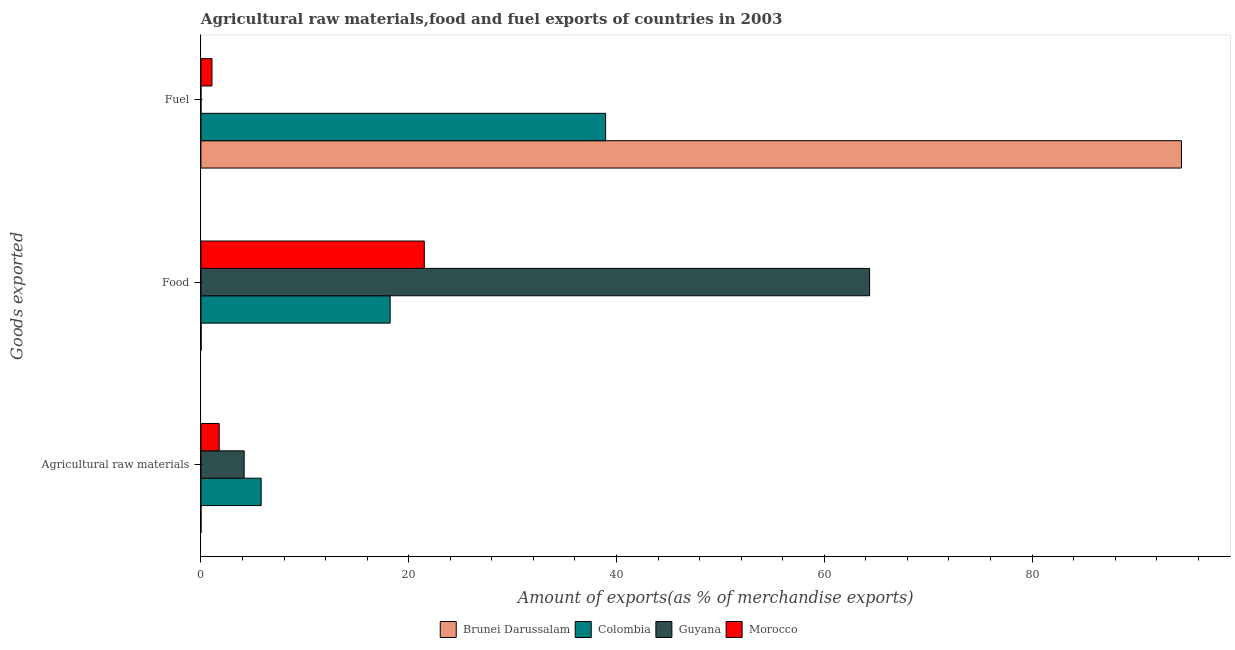How many bars are there on the 1st tick from the top?
Provide a short and direct response. 4. How many bars are there on the 2nd tick from the bottom?
Provide a short and direct response. 4. What is the label of the 1st group of bars from the top?
Keep it short and to the point. Fuel. What is the percentage of raw materials exports in Colombia?
Offer a terse response. 5.8. Across all countries, what is the maximum percentage of raw materials exports?
Give a very brief answer. 5.8. Across all countries, what is the minimum percentage of food exports?
Your response must be concise. 0.02. In which country was the percentage of food exports maximum?
Offer a very short reply. Guyana. In which country was the percentage of fuel exports minimum?
Your answer should be very brief. Guyana. What is the total percentage of food exports in the graph?
Make the answer very short. 104.1. What is the difference between the percentage of food exports in Colombia and that in Morocco?
Offer a terse response. -3.29. What is the difference between the percentage of raw materials exports in Morocco and the percentage of fuel exports in Colombia?
Provide a short and direct response. -37.2. What is the average percentage of fuel exports per country?
Provide a short and direct response. 33.6. What is the difference between the percentage of raw materials exports and percentage of food exports in Colombia?
Offer a terse response. -12.42. In how many countries, is the percentage of fuel exports greater than 60 %?
Offer a terse response. 1. What is the ratio of the percentage of fuel exports in Colombia to that in Brunei Darussalam?
Ensure brevity in your answer.  0.41. Is the percentage of food exports in Brunei Darussalam less than that in Colombia?
Your response must be concise. Yes. What is the difference between the highest and the second highest percentage of food exports?
Offer a very short reply. 42.86. What is the difference between the highest and the lowest percentage of raw materials exports?
Offer a very short reply. 5.8. What does the 1st bar from the bottom in Food represents?
Provide a succinct answer. Brunei Darussalam. Is it the case that in every country, the sum of the percentage of raw materials exports and percentage of food exports is greater than the percentage of fuel exports?
Make the answer very short. No. Are all the bars in the graph horizontal?
Make the answer very short. Yes. How many countries are there in the graph?
Ensure brevity in your answer.  4. Does the graph contain any zero values?
Make the answer very short. No. Does the graph contain grids?
Provide a succinct answer. No. Where does the legend appear in the graph?
Keep it short and to the point. Bottom center. What is the title of the graph?
Offer a terse response. Agricultural raw materials,food and fuel exports of countries in 2003. What is the label or title of the X-axis?
Offer a very short reply. Amount of exports(as % of merchandise exports). What is the label or title of the Y-axis?
Offer a very short reply. Goods exported. What is the Amount of exports(as % of merchandise exports) of Brunei Darussalam in Agricultural raw materials?
Offer a terse response. 0. What is the Amount of exports(as % of merchandise exports) in Colombia in Agricultural raw materials?
Keep it short and to the point. 5.8. What is the Amount of exports(as % of merchandise exports) in Guyana in Agricultural raw materials?
Ensure brevity in your answer.  4.16. What is the Amount of exports(as % of merchandise exports) of Morocco in Agricultural raw materials?
Make the answer very short. 1.76. What is the Amount of exports(as % of merchandise exports) of Brunei Darussalam in Food?
Offer a terse response. 0.02. What is the Amount of exports(as % of merchandise exports) in Colombia in Food?
Make the answer very short. 18.22. What is the Amount of exports(as % of merchandise exports) in Guyana in Food?
Your answer should be very brief. 64.36. What is the Amount of exports(as % of merchandise exports) in Morocco in Food?
Offer a terse response. 21.5. What is the Amount of exports(as % of merchandise exports) in Brunei Darussalam in Fuel?
Your answer should be very brief. 94.38. What is the Amount of exports(as % of merchandise exports) of Colombia in Fuel?
Offer a terse response. 38.95. What is the Amount of exports(as % of merchandise exports) of Guyana in Fuel?
Your response must be concise. 0. What is the Amount of exports(as % of merchandise exports) in Morocco in Fuel?
Your answer should be compact. 1.06. Across all Goods exported, what is the maximum Amount of exports(as % of merchandise exports) in Brunei Darussalam?
Your answer should be compact. 94.38. Across all Goods exported, what is the maximum Amount of exports(as % of merchandise exports) of Colombia?
Make the answer very short. 38.95. Across all Goods exported, what is the maximum Amount of exports(as % of merchandise exports) of Guyana?
Offer a terse response. 64.36. Across all Goods exported, what is the maximum Amount of exports(as % of merchandise exports) of Morocco?
Keep it short and to the point. 21.5. Across all Goods exported, what is the minimum Amount of exports(as % of merchandise exports) in Brunei Darussalam?
Your response must be concise. 0. Across all Goods exported, what is the minimum Amount of exports(as % of merchandise exports) in Colombia?
Your response must be concise. 5.8. Across all Goods exported, what is the minimum Amount of exports(as % of merchandise exports) of Guyana?
Make the answer very short. 0. Across all Goods exported, what is the minimum Amount of exports(as % of merchandise exports) of Morocco?
Provide a short and direct response. 1.06. What is the total Amount of exports(as % of merchandise exports) in Brunei Darussalam in the graph?
Provide a succinct answer. 94.41. What is the total Amount of exports(as % of merchandise exports) in Colombia in the graph?
Ensure brevity in your answer.  62.97. What is the total Amount of exports(as % of merchandise exports) of Guyana in the graph?
Keep it short and to the point. 68.53. What is the total Amount of exports(as % of merchandise exports) of Morocco in the graph?
Your response must be concise. 24.32. What is the difference between the Amount of exports(as % of merchandise exports) in Brunei Darussalam in Agricultural raw materials and that in Food?
Your answer should be very brief. -0.02. What is the difference between the Amount of exports(as % of merchandise exports) in Colombia in Agricultural raw materials and that in Food?
Give a very brief answer. -12.42. What is the difference between the Amount of exports(as % of merchandise exports) in Guyana in Agricultural raw materials and that in Food?
Ensure brevity in your answer.  -60.2. What is the difference between the Amount of exports(as % of merchandise exports) in Morocco in Agricultural raw materials and that in Food?
Provide a short and direct response. -19.74. What is the difference between the Amount of exports(as % of merchandise exports) in Brunei Darussalam in Agricultural raw materials and that in Fuel?
Give a very brief answer. -94.38. What is the difference between the Amount of exports(as % of merchandise exports) of Colombia in Agricultural raw materials and that in Fuel?
Offer a terse response. -33.15. What is the difference between the Amount of exports(as % of merchandise exports) of Guyana in Agricultural raw materials and that in Fuel?
Keep it short and to the point. 4.16. What is the difference between the Amount of exports(as % of merchandise exports) of Morocco in Agricultural raw materials and that in Fuel?
Give a very brief answer. 0.7. What is the difference between the Amount of exports(as % of merchandise exports) in Brunei Darussalam in Food and that in Fuel?
Provide a short and direct response. -94.36. What is the difference between the Amount of exports(as % of merchandise exports) of Colombia in Food and that in Fuel?
Provide a short and direct response. -20.74. What is the difference between the Amount of exports(as % of merchandise exports) in Guyana in Food and that in Fuel?
Ensure brevity in your answer.  64.36. What is the difference between the Amount of exports(as % of merchandise exports) in Morocco in Food and that in Fuel?
Provide a short and direct response. 20.44. What is the difference between the Amount of exports(as % of merchandise exports) in Brunei Darussalam in Agricultural raw materials and the Amount of exports(as % of merchandise exports) in Colombia in Food?
Provide a succinct answer. -18.21. What is the difference between the Amount of exports(as % of merchandise exports) in Brunei Darussalam in Agricultural raw materials and the Amount of exports(as % of merchandise exports) in Guyana in Food?
Offer a very short reply. -64.36. What is the difference between the Amount of exports(as % of merchandise exports) of Brunei Darussalam in Agricultural raw materials and the Amount of exports(as % of merchandise exports) of Morocco in Food?
Make the answer very short. -21.5. What is the difference between the Amount of exports(as % of merchandise exports) of Colombia in Agricultural raw materials and the Amount of exports(as % of merchandise exports) of Guyana in Food?
Ensure brevity in your answer.  -58.56. What is the difference between the Amount of exports(as % of merchandise exports) of Colombia in Agricultural raw materials and the Amount of exports(as % of merchandise exports) of Morocco in Food?
Your answer should be compact. -15.7. What is the difference between the Amount of exports(as % of merchandise exports) of Guyana in Agricultural raw materials and the Amount of exports(as % of merchandise exports) of Morocco in Food?
Offer a terse response. -17.34. What is the difference between the Amount of exports(as % of merchandise exports) of Brunei Darussalam in Agricultural raw materials and the Amount of exports(as % of merchandise exports) of Colombia in Fuel?
Give a very brief answer. -38.95. What is the difference between the Amount of exports(as % of merchandise exports) of Brunei Darussalam in Agricultural raw materials and the Amount of exports(as % of merchandise exports) of Guyana in Fuel?
Offer a terse response. 0. What is the difference between the Amount of exports(as % of merchandise exports) of Brunei Darussalam in Agricultural raw materials and the Amount of exports(as % of merchandise exports) of Morocco in Fuel?
Provide a short and direct response. -1.06. What is the difference between the Amount of exports(as % of merchandise exports) in Colombia in Agricultural raw materials and the Amount of exports(as % of merchandise exports) in Guyana in Fuel?
Offer a terse response. 5.8. What is the difference between the Amount of exports(as % of merchandise exports) in Colombia in Agricultural raw materials and the Amount of exports(as % of merchandise exports) in Morocco in Fuel?
Offer a terse response. 4.74. What is the difference between the Amount of exports(as % of merchandise exports) in Guyana in Agricultural raw materials and the Amount of exports(as % of merchandise exports) in Morocco in Fuel?
Your answer should be very brief. 3.1. What is the difference between the Amount of exports(as % of merchandise exports) of Brunei Darussalam in Food and the Amount of exports(as % of merchandise exports) of Colombia in Fuel?
Offer a very short reply. -38.93. What is the difference between the Amount of exports(as % of merchandise exports) in Brunei Darussalam in Food and the Amount of exports(as % of merchandise exports) in Guyana in Fuel?
Provide a succinct answer. 0.02. What is the difference between the Amount of exports(as % of merchandise exports) in Brunei Darussalam in Food and the Amount of exports(as % of merchandise exports) in Morocco in Fuel?
Keep it short and to the point. -1.04. What is the difference between the Amount of exports(as % of merchandise exports) in Colombia in Food and the Amount of exports(as % of merchandise exports) in Guyana in Fuel?
Provide a short and direct response. 18.21. What is the difference between the Amount of exports(as % of merchandise exports) of Colombia in Food and the Amount of exports(as % of merchandise exports) of Morocco in Fuel?
Provide a short and direct response. 17.15. What is the difference between the Amount of exports(as % of merchandise exports) in Guyana in Food and the Amount of exports(as % of merchandise exports) in Morocco in Fuel?
Make the answer very short. 63.3. What is the average Amount of exports(as % of merchandise exports) in Brunei Darussalam per Goods exported?
Offer a very short reply. 31.47. What is the average Amount of exports(as % of merchandise exports) in Colombia per Goods exported?
Ensure brevity in your answer.  20.99. What is the average Amount of exports(as % of merchandise exports) in Guyana per Goods exported?
Offer a terse response. 22.84. What is the average Amount of exports(as % of merchandise exports) of Morocco per Goods exported?
Your answer should be compact. 8.11. What is the difference between the Amount of exports(as % of merchandise exports) in Brunei Darussalam and Amount of exports(as % of merchandise exports) in Colombia in Agricultural raw materials?
Offer a terse response. -5.8. What is the difference between the Amount of exports(as % of merchandise exports) in Brunei Darussalam and Amount of exports(as % of merchandise exports) in Guyana in Agricultural raw materials?
Your answer should be very brief. -4.16. What is the difference between the Amount of exports(as % of merchandise exports) in Brunei Darussalam and Amount of exports(as % of merchandise exports) in Morocco in Agricultural raw materials?
Provide a short and direct response. -1.75. What is the difference between the Amount of exports(as % of merchandise exports) of Colombia and Amount of exports(as % of merchandise exports) of Guyana in Agricultural raw materials?
Keep it short and to the point. 1.64. What is the difference between the Amount of exports(as % of merchandise exports) in Colombia and Amount of exports(as % of merchandise exports) in Morocco in Agricultural raw materials?
Give a very brief answer. 4.04. What is the difference between the Amount of exports(as % of merchandise exports) of Guyana and Amount of exports(as % of merchandise exports) of Morocco in Agricultural raw materials?
Make the answer very short. 2.4. What is the difference between the Amount of exports(as % of merchandise exports) of Brunei Darussalam and Amount of exports(as % of merchandise exports) of Colombia in Food?
Your answer should be very brief. -18.2. What is the difference between the Amount of exports(as % of merchandise exports) of Brunei Darussalam and Amount of exports(as % of merchandise exports) of Guyana in Food?
Offer a terse response. -64.34. What is the difference between the Amount of exports(as % of merchandise exports) in Brunei Darussalam and Amount of exports(as % of merchandise exports) in Morocco in Food?
Your response must be concise. -21.48. What is the difference between the Amount of exports(as % of merchandise exports) of Colombia and Amount of exports(as % of merchandise exports) of Guyana in Food?
Make the answer very short. -46.15. What is the difference between the Amount of exports(as % of merchandise exports) in Colombia and Amount of exports(as % of merchandise exports) in Morocco in Food?
Offer a terse response. -3.29. What is the difference between the Amount of exports(as % of merchandise exports) of Guyana and Amount of exports(as % of merchandise exports) of Morocco in Food?
Your response must be concise. 42.86. What is the difference between the Amount of exports(as % of merchandise exports) in Brunei Darussalam and Amount of exports(as % of merchandise exports) in Colombia in Fuel?
Offer a terse response. 55.43. What is the difference between the Amount of exports(as % of merchandise exports) of Brunei Darussalam and Amount of exports(as % of merchandise exports) of Guyana in Fuel?
Offer a terse response. 94.38. What is the difference between the Amount of exports(as % of merchandise exports) of Brunei Darussalam and Amount of exports(as % of merchandise exports) of Morocco in Fuel?
Your response must be concise. 93.32. What is the difference between the Amount of exports(as % of merchandise exports) in Colombia and Amount of exports(as % of merchandise exports) in Guyana in Fuel?
Keep it short and to the point. 38.95. What is the difference between the Amount of exports(as % of merchandise exports) in Colombia and Amount of exports(as % of merchandise exports) in Morocco in Fuel?
Your response must be concise. 37.89. What is the difference between the Amount of exports(as % of merchandise exports) of Guyana and Amount of exports(as % of merchandise exports) of Morocco in Fuel?
Offer a very short reply. -1.06. What is the ratio of the Amount of exports(as % of merchandise exports) of Brunei Darussalam in Agricultural raw materials to that in Food?
Provide a succinct answer. 0.23. What is the ratio of the Amount of exports(as % of merchandise exports) in Colombia in Agricultural raw materials to that in Food?
Offer a terse response. 0.32. What is the ratio of the Amount of exports(as % of merchandise exports) in Guyana in Agricultural raw materials to that in Food?
Your response must be concise. 0.06. What is the ratio of the Amount of exports(as % of merchandise exports) in Morocco in Agricultural raw materials to that in Food?
Provide a succinct answer. 0.08. What is the ratio of the Amount of exports(as % of merchandise exports) of Brunei Darussalam in Agricultural raw materials to that in Fuel?
Offer a terse response. 0. What is the ratio of the Amount of exports(as % of merchandise exports) in Colombia in Agricultural raw materials to that in Fuel?
Your answer should be very brief. 0.15. What is the ratio of the Amount of exports(as % of merchandise exports) in Guyana in Agricultural raw materials to that in Fuel?
Make the answer very short. 2805.7. What is the ratio of the Amount of exports(as % of merchandise exports) in Morocco in Agricultural raw materials to that in Fuel?
Provide a succinct answer. 1.65. What is the ratio of the Amount of exports(as % of merchandise exports) of Colombia in Food to that in Fuel?
Your answer should be compact. 0.47. What is the ratio of the Amount of exports(as % of merchandise exports) in Guyana in Food to that in Fuel?
Offer a terse response. 4.34e+04. What is the ratio of the Amount of exports(as % of merchandise exports) of Morocco in Food to that in Fuel?
Provide a succinct answer. 20.23. What is the difference between the highest and the second highest Amount of exports(as % of merchandise exports) of Brunei Darussalam?
Offer a terse response. 94.36. What is the difference between the highest and the second highest Amount of exports(as % of merchandise exports) of Colombia?
Offer a very short reply. 20.74. What is the difference between the highest and the second highest Amount of exports(as % of merchandise exports) in Guyana?
Offer a terse response. 60.2. What is the difference between the highest and the second highest Amount of exports(as % of merchandise exports) of Morocco?
Offer a very short reply. 19.74. What is the difference between the highest and the lowest Amount of exports(as % of merchandise exports) of Brunei Darussalam?
Your answer should be compact. 94.38. What is the difference between the highest and the lowest Amount of exports(as % of merchandise exports) of Colombia?
Your answer should be compact. 33.15. What is the difference between the highest and the lowest Amount of exports(as % of merchandise exports) of Guyana?
Provide a short and direct response. 64.36. What is the difference between the highest and the lowest Amount of exports(as % of merchandise exports) of Morocco?
Give a very brief answer. 20.44. 